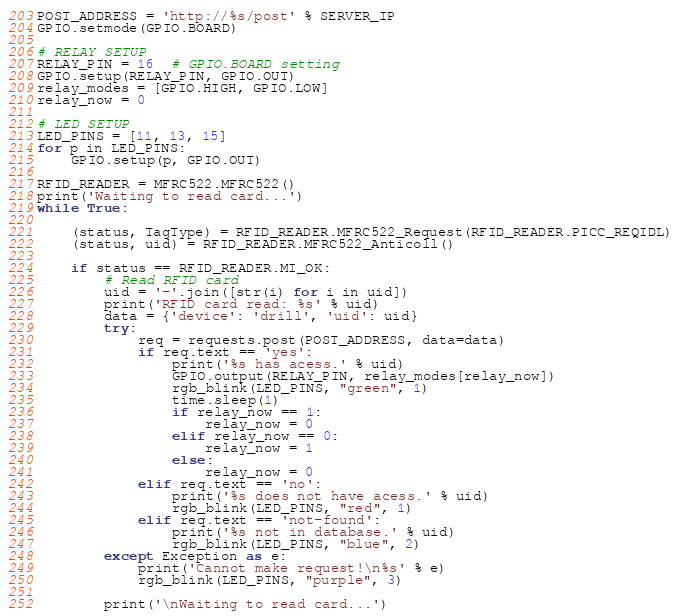Convert code to text. <code><loc_0><loc_0><loc_500><loc_500><_Python_>POST_ADDRESS = 'http://%s/post' % SERVER_IP
GPIO.setmode(GPIO.BOARD)

# RELAY SETUP
RELAY_PIN = 16  # GPIO.BOARD setting
GPIO.setup(RELAY_PIN, GPIO.OUT)
relay_modes = [GPIO.HIGH, GPIO.LOW]
relay_now = 0

# LED SETUP
LED_PINS = [11, 13, 15]
for p in LED_PINS:
    GPIO.setup(p, GPIO.OUT)

RFID_READER = MFRC522.MFRC522()
print('Waiting to read card...')
while True:

    (status, TagType) = RFID_READER.MFRC522_Request(RFID_READER.PICC_REQIDL)
    (status, uid) = RFID_READER.MFRC522_Anticoll()

    if status == RFID_READER.MI_OK:
        # Read RFID card
        uid = '-'.join([str(i) for i in uid])
        print('RFID card read: %s' % uid)
        data = {'device': 'drill', 'uid': uid}
        try:
            req = requests.post(POST_ADDRESS, data=data)
            if req.text == 'yes':
                print('%s has acess.' % uid)
                GPIO.output(RELAY_PIN, relay_modes[relay_now])
                rgb_blink(LED_PINS, "green", 1)
                time.sleep(1)
                if relay_now == 1:
                    relay_now = 0
                elif relay_now == 0:
                    relay_now = 1
                else:
                    relay_now = 0
            elif req.text == 'no':
                print('%s does not have acess.' % uid)
                rgb_blink(LED_PINS, "red", 1)
            elif req.text == 'not-found':
                print('%s not in database.' % uid)
                rgb_blink(LED_PINS, "blue", 2)
        except Exception as e:
            print('Cannot make request!\n%s' % e)
            rgb_blink(LED_PINS, "purple", 3)

        print('\nWaiting to read card...')
</code> 